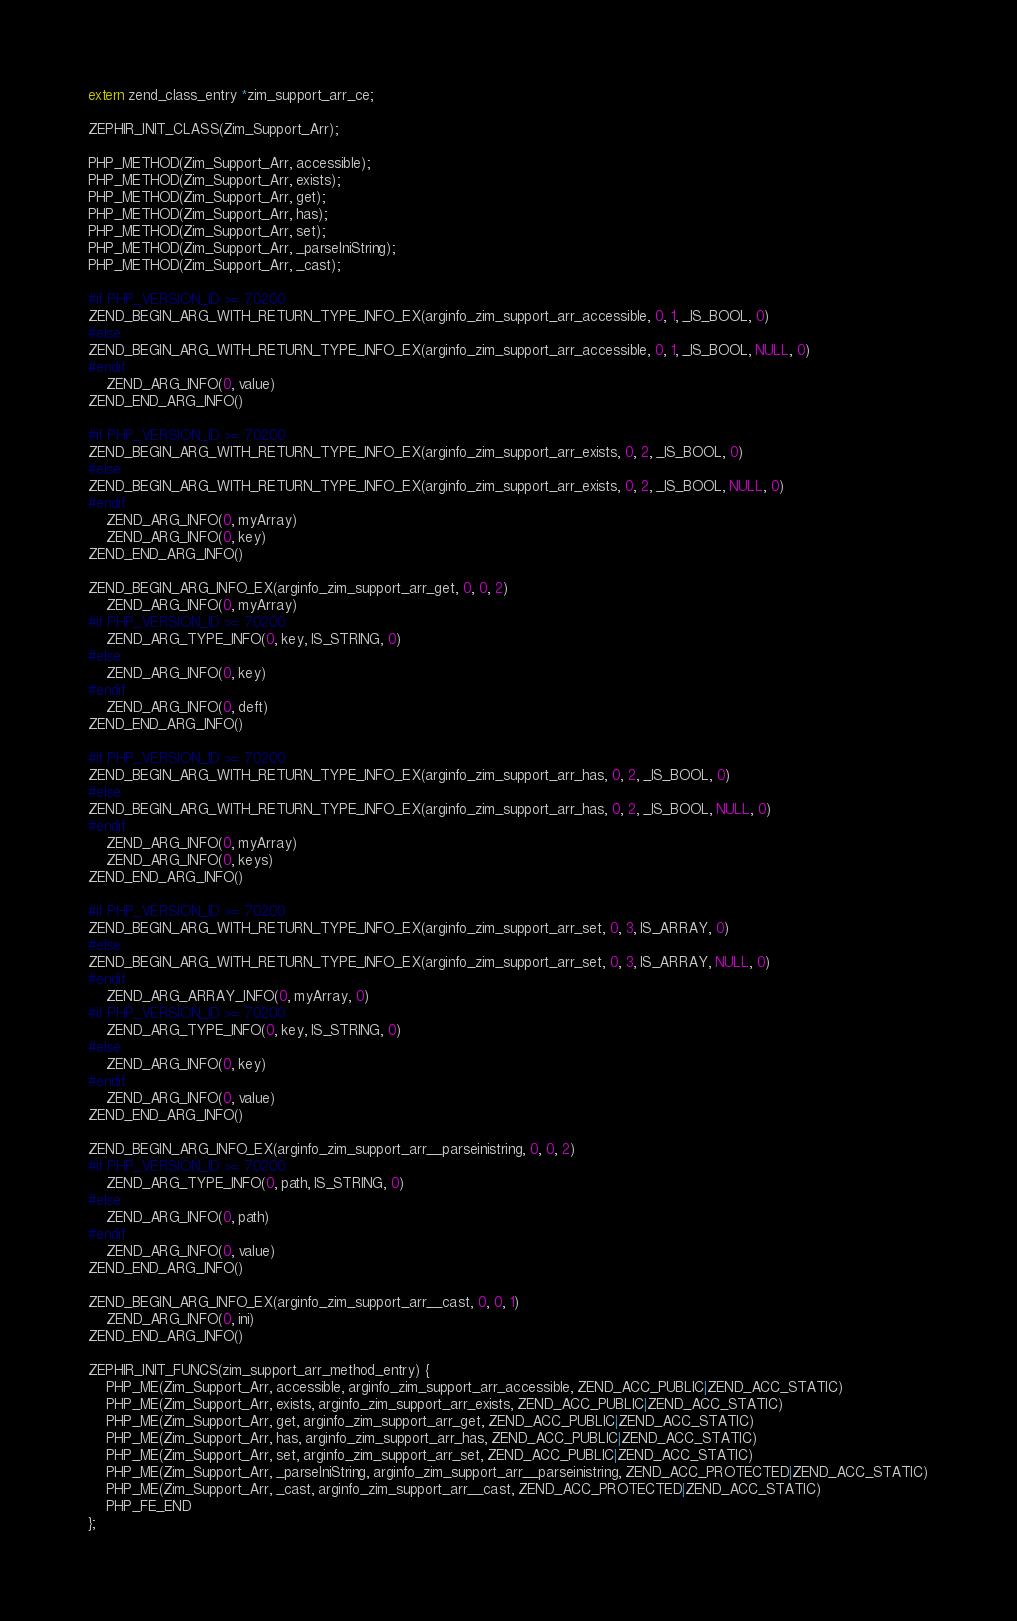<code> <loc_0><loc_0><loc_500><loc_500><_C_>
extern zend_class_entry *zim_support_arr_ce;

ZEPHIR_INIT_CLASS(Zim_Support_Arr);

PHP_METHOD(Zim_Support_Arr, accessible);
PHP_METHOD(Zim_Support_Arr, exists);
PHP_METHOD(Zim_Support_Arr, get);
PHP_METHOD(Zim_Support_Arr, has);
PHP_METHOD(Zim_Support_Arr, set);
PHP_METHOD(Zim_Support_Arr, _parseIniString);
PHP_METHOD(Zim_Support_Arr, _cast);

#if PHP_VERSION_ID >= 70200
ZEND_BEGIN_ARG_WITH_RETURN_TYPE_INFO_EX(arginfo_zim_support_arr_accessible, 0, 1, _IS_BOOL, 0)
#else
ZEND_BEGIN_ARG_WITH_RETURN_TYPE_INFO_EX(arginfo_zim_support_arr_accessible, 0, 1, _IS_BOOL, NULL, 0)
#endif
	ZEND_ARG_INFO(0, value)
ZEND_END_ARG_INFO()

#if PHP_VERSION_ID >= 70200
ZEND_BEGIN_ARG_WITH_RETURN_TYPE_INFO_EX(arginfo_zim_support_arr_exists, 0, 2, _IS_BOOL, 0)
#else
ZEND_BEGIN_ARG_WITH_RETURN_TYPE_INFO_EX(arginfo_zim_support_arr_exists, 0, 2, _IS_BOOL, NULL, 0)
#endif
	ZEND_ARG_INFO(0, myArray)
	ZEND_ARG_INFO(0, key)
ZEND_END_ARG_INFO()

ZEND_BEGIN_ARG_INFO_EX(arginfo_zim_support_arr_get, 0, 0, 2)
	ZEND_ARG_INFO(0, myArray)
#if PHP_VERSION_ID >= 70200
	ZEND_ARG_TYPE_INFO(0, key, IS_STRING, 0)
#else
	ZEND_ARG_INFO(0, key)
#endif
	ZEND_ARG_INFO(0, deft)
ZEND_END_ARG_INFO()

#if PHP_VERSION_ID >= 70200
ZEND_BEGIN_ARG_WITH_RETURN_TYPE_INFO_EX(arginfo_zim_support_arr_has, 0, 2, _IS_BOOL, 0)
#else
ZEND_BEGIN_ARG_WITH_RETURN_TYPE_INFO_EX(arginfo_zim_support_arr_has, 0, 2, _IS_BOOL, NULL, 0)
#endif
	ZEND_ARG_INFO(0, myArray)
	ZEND_ARG_INFO(0, keys)
ZEND_END_ARG_INFO()

#if PHP_VERSION_ID >= 70200
ZEND_BEGIN_ARG_WITH_RETURN_TYPE_INFO_EX(arginfo_zim_support_arr_set, 0, 3, IS_ARRAY, 0)
#else
ZEND_BEGIN_ARG_WITH_RETURN_TYPE_INFO_EX(arginfo_zim_support_arr_set, 0, 3, IS_ARRAY, NULL, 0)
#endif
	ZEND_ARG_ARRAY_INFO(0, myArray, 0)
#if PHP_VERSION_ID >= 70200
	ZEND_ARG_TYPE_INFO(0, key, IS_STRING, 0)
#else
	ZEND_ARG_INFO(0, key)
#endif
	ZEND_ARG_INFO(0, value)
ZEND_END_ARG_INFO()

ZEND_BEGIN_ARG_INFO_EX(arginfo_zim_support_arr__parseinistring, 0, 0, 2)
#if PHP_VERSION_ID >= 70200
	ZEND_ARG_TYPE_INFO(0, path, IS_STRING, 0)
#else
	ZEND_ARG_INFO(0, path)
#endif
	ZEND_ARG_INFO(0, value)
ZEND_END_ARG_INFO()

ZEND_BEGIN_ARG_INFO_EX(arginfo_zim_support_arr__cast, 0, 0, 1)
	ZEND_ARG_INFO(0, ini)
ZEND_END_ARG_INFO()

ZEPHIR_INIT_FUNCS(zim_support_arr_method_entry) {
	PHP_ME(Zim_Support_Arr, accessible, arginfo_zim_support_arr_accessible, ZEND_ACC_PUBLIC|ZEND_ACC_STATIC)
	PHP_ME(Zim_Support_Arr, exists, arginfo_zim_support_arr_exists, ZEND_ACC_PUBLIC|ZEND_ACC_STATIC)
	PHP_ME(Zim_Support_Arr, get, arginfo_zim_support_arr_get, ZEND_ACC_PUBLIC|ZEND_ACC_STATIC)
	PHP_ME(Zim_Support_Arr, has, arginfo_zim_support_arr_has, ZEND_ACC_PUBLIC|ZEND_ACC_STATIC)
	PHP_ME(Zim_Support_Arr, set, arginfo_zim_support_arr_set, ZEND_ACC_PUBLIC|ZEND_ACC_STATIC)
	PHP_ME(Zim_Support_Arr, _parseIniString, arginfo_zim_support_arr__parseinistring, ZEND_ACC_PROTECTED|ZEND_ACC_STATIC)
	PHP_ME(Zim_Support_Arr, _cast, arginfo_zim_support_arr__cast, ZEND_ACC_PROTECTED|ZEND_ACC_STATIC)
	PHP_FE_END
};
</code> 